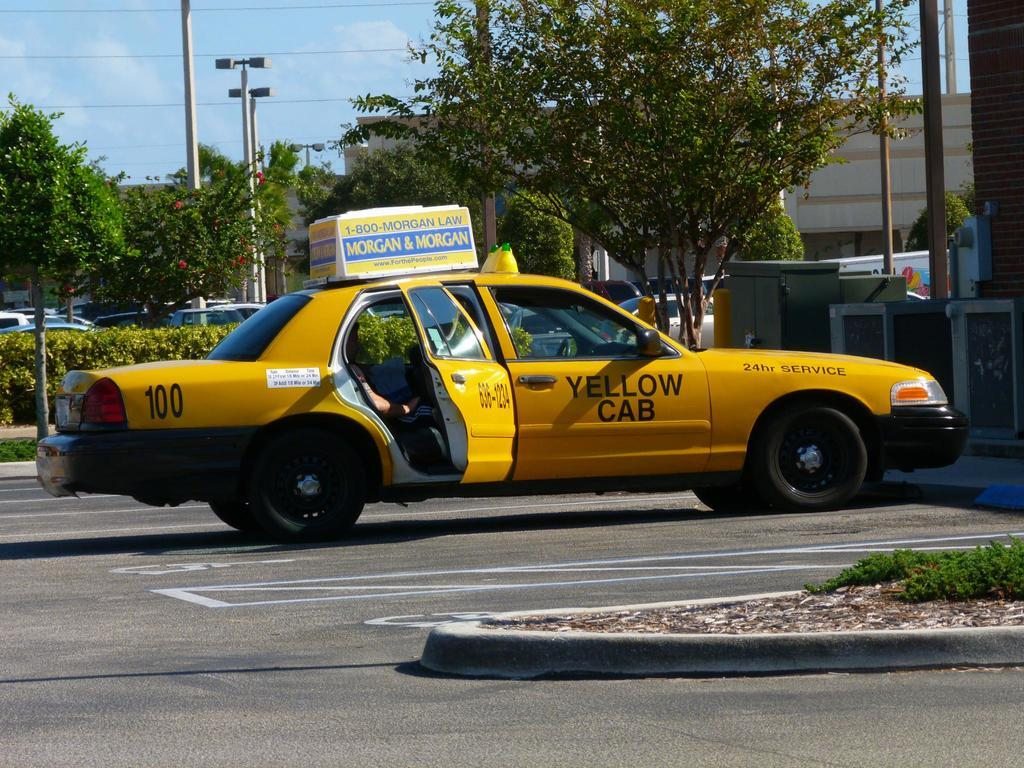<image>
Describe the image concisely. Yellow Cab number 100 is parked outside in a parking lot. 